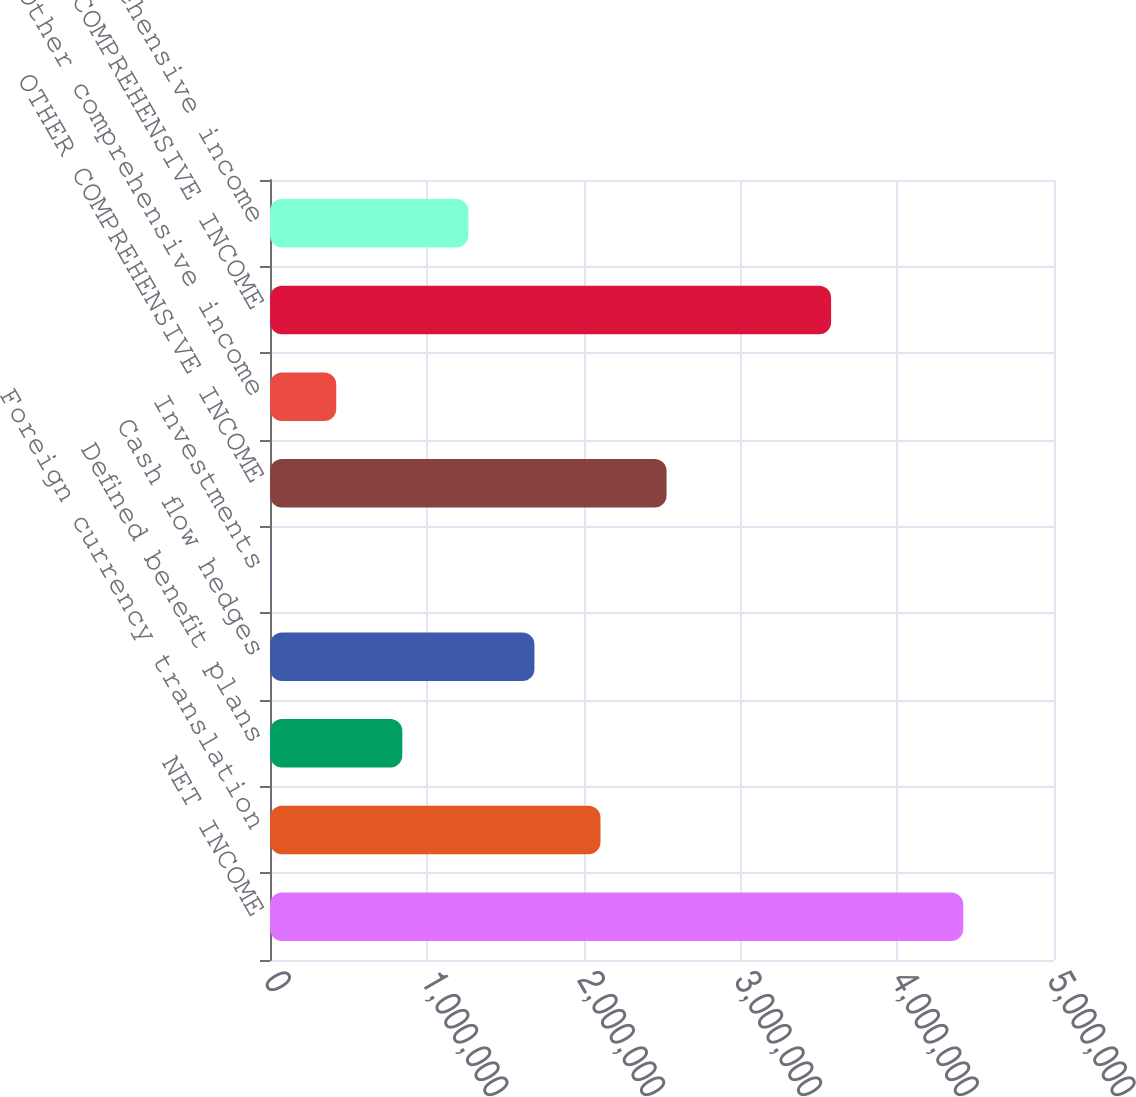Convert chart to OTSL. <chart><loc_0><loc_0><loc_500><loc_500><bar_chart><fcel>NET INCOME<fcel>Foreign currency translation<fcel>Defined benefit plans<fcel>Cash flow hedges<fcel>Investments<fcel>OTHER COMPREHENSIVE INCOME<fcel>Other comprehensive income<fcel>COMPREHENSIVE INCOME<fcel>Comprehensive income<nl><fcel>4.42121e+06<fcel>2.10787e+06<fcel>843837<fcel>1.68653e+06<fcel>1148<fcel>2.52922e+06<fcel>422493<fcel>3.57852e+06<fcel>1.26518e+06<nl></chart> 